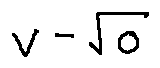Convert formula to latex. <formula><loc_0><loc_0><loc_500><loc_500>v - \sqrt { o }</formula> 